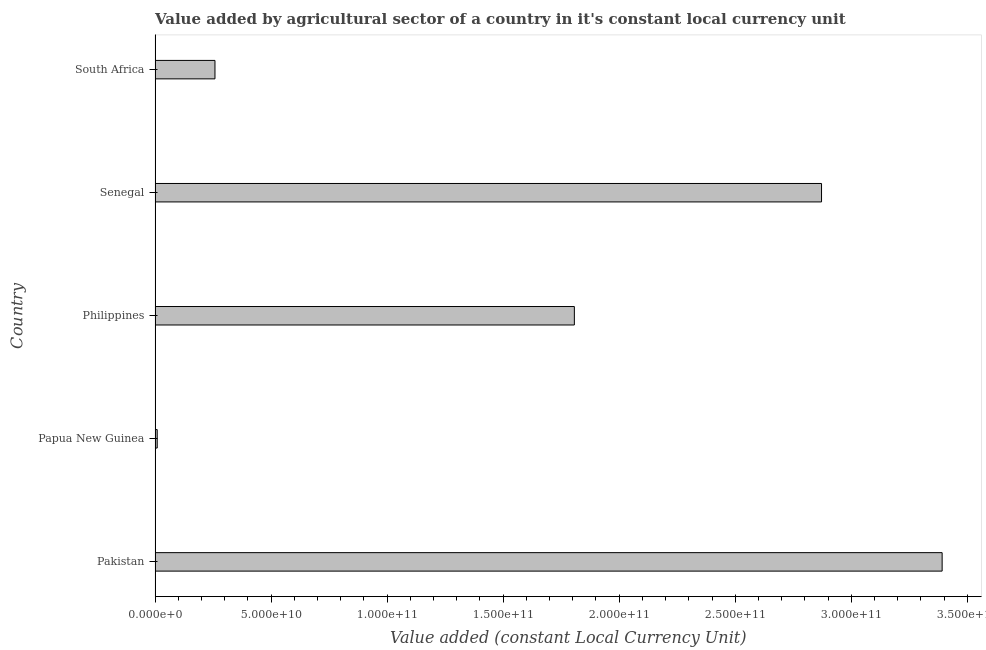Does the graph contain grids?
Make the answer very short. No. What is the title of the graph?
Provide a short and direct response. Value added by agricultural sector of a country in it's constant local currency unit. What is the label or title of the X-axis?
Provide a succinct answer. Value added (constant Local Currency Unit). What is the value added by agriculture sector in Philippines?
Offer a very short reply. 1.81e+11. Across all countries, what is the maximum value added by agriculture sector?
Offer a very short reply. 3.39e+11. Across all countries, what is the minimum value added by agriculture sector?
Ensure brevity in your answer.  9.31e+08. In which country was the value added by agriculture sector maximum?
Your answer should be very brief. Pakistan. In which country was the value added by agriculture sector minimum?
Give a very brief answer. Papua New Guinea. What is the sum of the value added by agriculture sector?
Provide a succinct answer. 8.34e+11. What is the difference between the value added by agriculture sector in Philippines and Senegal?
Give a very brief answer. -1.07e+11. What is the average value added by agriculture sector per country?
Offer a very short reply. 1.67e+11. What is the median value added by agriculture sector?
Give a very brief answer. 1.81e+11. What is the ratio of the value added by agriculture sector in Pakistan to that in Philippines?
Provide a succinct answer. 1.88. Is the value added by agriculture sector in Senegal less than that in South Africa?
Provide a succinct answer. No. What is the difference between the highest and the second highest value added by agriculture sector?
Provide a short and direct response. 5.20e+1. Is the sum of the value added by agriculture sector in Pakistan and Papua New Guinea greater than the maximum value added by agriculture sector across all countries?
Keep it short and to the point. Yes. What is the difference between the highest and the lowest value added by agriculture sector?
Your answer should be very brief. 3.38e+11. In how many countries, is the value added by agriculture sector greater than the average value added by agriculture sector taken over all countries?
Your answer should be compact. 3. How many bars are there?
Your response must be concise. 5. How many countries are there in the graph?
Ensure brevity in your answer.  5. What is the Value added (constant Local Currency Unit) in Pakistan?
Make the answer very short. 3.39e+11. What is the Value added (constant Local Currency Unit) in Papua New Guinea?
Offer a very short reply. 9.31e+08. What is the Value added (constant Local Currency Unit) of Philippines?
Offer a terse response. 1.81e+11. What is the Value added (constant Local Currency Unit) in Senegal?
Keep it short and to the point. 2.87e+11. What is the Value added (constant Local Currency Unit) in South Africa?
Your response must be concise. 2.58e+1. What is the difference between the Value added (constant Local Currency Unit) in Pakistan and Papua New Guinea?
Your answer should be very brief. 3.38e+11. What is the difference between the Value added (constant Local Currency Unit) in Pakistan and Philippines?
Give a very brief answer. 1.58e+11. What is the difference between the Value added (constant Local Currency Unit) in Pakistan and Senegal?
Offer a very short reply. 5.20e+1. What is the difference between the Value added (constant Local Currency Unit) in Pakistan and South Africa?
Give a very brief answer. 3.13e+11. What is the difference between the Value added (constant Local Currency Unit) in Papua New Guinea and Philippines?
Give a very brief answer. -1.80e+11. What is the difference between the Value added (constant Local Currency Unit) in Papua New Guinea and Senegal?
Your answer should be very brief. -2.86e+11. What is the difference between the Value added (constant Local Currency Unit) in Papua New Guinea and South Africa?
Keep it short and to the point. -2.49e+1. What is the difference between the Value added (constant Local Currency Unit) in Philippines and Senegal?
Provide a short and direct response. -1.07e+11. What is the difference between the Value added (constant Local Currency Unit) in Philippines and South Africa?
Offer a terse response. 1.55e+11. What is the difference between the Value added (constant Local Currency Unit) in Senegal and South Africa?
Make the answer very short. 2.61e+11. What is the ratio of the Value added (constant Local Currency Unit) in Pakistan to that in Papua New Guinea?
Ensure brevity in your answer.  364.44. What is the ratio of the Value added (constant Local Currency Unit) in Pakistan to that in Philippines?
Offer a terse response. 1.88. What is the ratio of the Value added (constant Local Currency Unit) in Pakistan to that in Senegal?
Your answer should be very brief. 1.18. What is the ratio of the Value added (constant Local Currency Unit) in Pakistan to that in South Africa?
Make the answer very short. 13.14. What is the ratio of the Value added (constant Local Currency Unit) in Papua New Guinea to that in Philippines?
Provide a short and direct response. 0.01. What is the ratio of the Value added (constant Local Currency Unit) in Papua New Guinea to that in Senegal?
Your response must be concise. 0. What is the ratio of the Value added (constant Local Currency Unit) in Papua New Guinea to that in South Africa?
Provide a short and direct response. 0.04. What is the ratio of the Value added (constant Local Currency Unit) in Philippines to that in Senegal?
Make the answer very short. 0.63. What is the ratio of the Value added (constant Local Currency Unit) in Philippines to that in South Africa?
Give a very brief answer. 7. What is the ratio of the Value added (constant Local Currency Unit) in Senegal to that in South Africa?
Give a very brief answer. 11.12. 